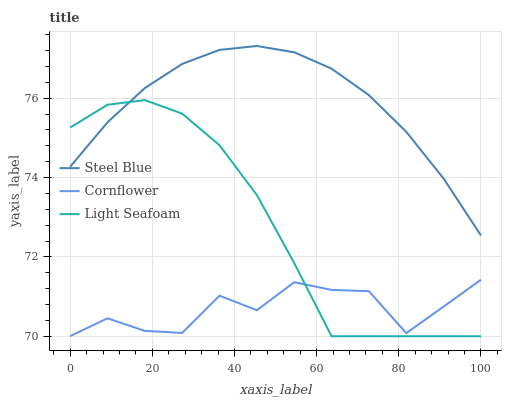Does Cornflower have the minimum area under the curve?
Answer yes or no. Yes. Does Steel Blue have the maximum area under the curve?
Answer yes or no. Yes. Does Light Seafoam have the minimum area under the curve?
Answer yes or no. No. Does Light Seafoam have the maximum area under the curve?
Answer yes or no. No. Is Steel Blue the smoothest?
Answer yes or no. Yes. Is Cornflower the roughest?
Answer yes or no. Yes. Is Light Seafoam the smoothest?
Answer yes or no. No. Is Light Seafoam the roughest?
Answer yes or no. No. Does Light Seafoam have the lowest value?
Answer yes or no. Yes. Does Steel Blue have the lowest value?
Answer yes or no. No. Does Steel Blue have the highest value?
Answer yes or no. Yes. Does Light Seafoam have the highest value?
Answer yes or no. No. Is Cornflower less than Steel Blue?
Answer yes or no. Yes. Is Steel Blue greater than Cornflower?
Answer yes or no. Yes. Does Light Seafoam intersect Cornflower?
Answer yes or no. Yes. Is Light Seafoam less than Cornflower?
Answer yes or no. No. Is Light Seafoam greater than Cornflower?
Answer yes or no. No. Does Cornflower intersect Steel Blue?
Answer yes or no. No. 